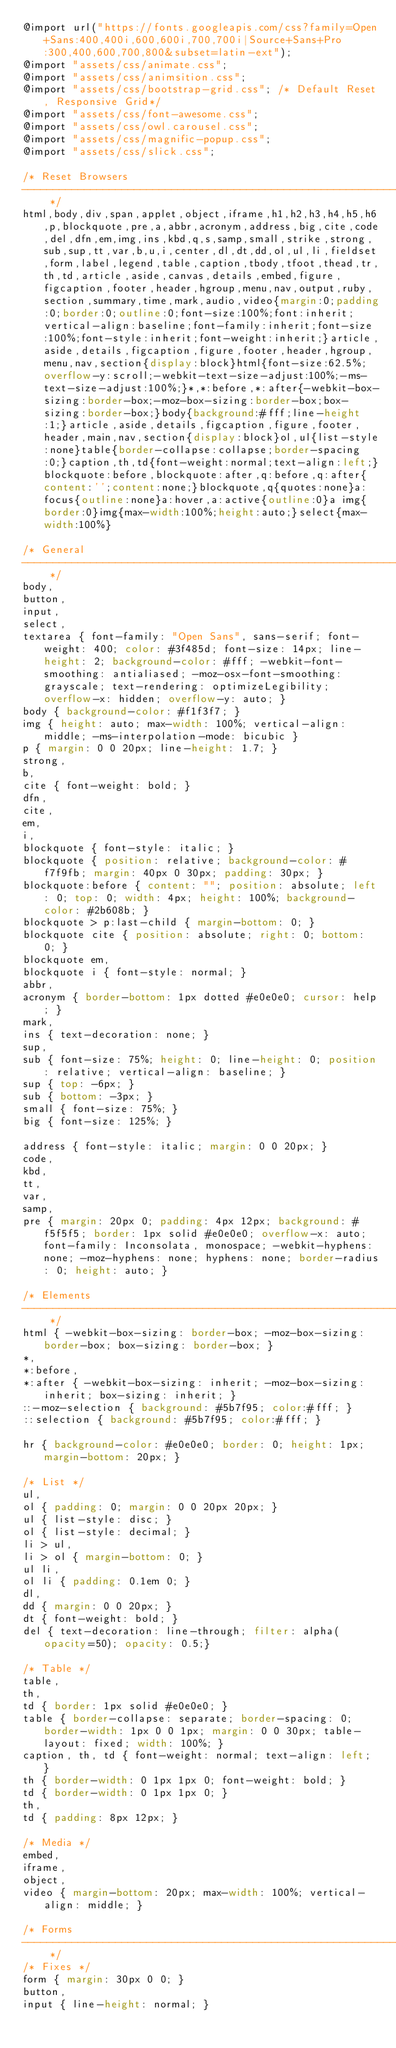<code> <loc_0><loc_0><loc_500><loc_500><_CSS_>@import url("https://fonts.googleapis.com/css?family=Open+Sans:400,400i,600,600i,700,700i|Source+Sans+Pro:300,400,600,700,800&subset=latin-ext");
@import "assets/css/animate.css";
@import "assets/css/animsition.css";
@import "assets/css/bootstrap-grid.css"; /* Default Reset, Responsive Grid*/
@import "assets/css/font-awesome.css";
@import "assets/css/owl.carousel.css";
@import "assets/css/magnific-popup.css";
@import "assets/css/slick.css";

/* Reset Browsers
-------------------------------------------------------------- */
html,body,div,span,applet,object,iframe,h1,h2,h3,h4,h5,h6,p,blockquote,pre,a,abbr,acronym,address,big,cite,code,del,dfn,em,img,ins,kbd,q,s,samp,small,strike,strong,sub,sup,tt,var,b,u,i,center,dl,dt,dd,ol,ul,li,fieldset,form,label,legend,table,caption,tbody,tfoot,thead,tr,th,td,article,aside,canvas,details,embed,figure,figcaption,footer,header,hgroup,menu,nav,output,ruby,section,summary,time,mark,audio,video{margin:0;padding:0;border:0;outline:0;font-size:100%;font:inherit;vertical-align:baseline;font-family:inherit;font-size:100%;font-style:inherit;font-weight:inherit;}article,aside,details,figcaption,figure,footer,header,hgroup,menu,nav,section{display:block}html{font-size:62.5%;overflow-y:scroll;-webkit-text-size-adjust:100%;-ms-text-size-adjust:100%;}*,*:before,*:after{-webkit-box-sizing:border-box;-moz-box-sizing:border-box;box-sizing:border-box;}body{background:#fff;line-height:1;}article,aside,details,figcaption,figure,footer,header,main,nav,section{display:block}ol,ul{list-style:none}table{border-collapse:collapse;border-spacing:0;}caption,th,td{font-weight:normal;text-align:left;}blockquote:before,blockquote:after,q:before,q:after{content:'';content:none;}blockquote,q{quotes:none}a:focus{outline:none}a:hover,a:active{outline:0}a img{border:0}img{max-width:100%;height:auto;}select{max-width:100%}

/* General
-------------------------------------------------------------- */
body,
button,
input,
select,
textarea { font-family: "Open Sans", sans-serif; font-weight: 400; color: #3f485d; font-size: 14px; line-height: 2; background-color: #fff; -webkit-font-smoothing: antialiased; -moz-osx-font-smoothing: grayscale; text-rendering: optimizeLegibility; overflow-x: hidden; overflow-y: auto; }
body { background-color: #f1f3f7; }
img { height: auto; max-width: 100%; vertical-align: middle; -ms-interpolation-mode: bicubic }
p { margin: 0 0 20px; line-height: 1.7; }
strong,
b,
cite { font-weight: bold; }
dfn,
cite,
em,
i,
blockquote { font-style: italic; }
blockquote { position: relative; background-color: #f7f9fb; margin: 40px 0 30px; padding: 30px; }
blockquote:before { content: ""; position: absolute; left: 0; top: 0; width: 4px; height: 100%; background-color: #2b608b; }
blockquote > p:last-child { margin-bottom: 0; }
blockquote cite { position: absolute; right: 0; bottom: 0; }
blockquote em,
blockquote i { font-style: normal; }
abbr,
acronym { border-bottom: 1px dotted #e0e0e0; cursor: help; }
mark,
ins { text-decoration: none; }
sup,
sub { font-size: 75%; height: 0; line-height: 0; position: relative; vertical-align: baseline; }
sup { top: -6px; }
sub { bottom: -3px; }
small { font-size: 75%; }
big { font-size: 125%; }

address { font-style: italic; margin: 0 0 20px; }
code,
kbd,
tt,
var,
samp,
pre { margin: 20px 0; padding: 4px 12px; background: #f5f5f5; border: 1px solid #e0e0e0; overflow-x: auto; font-family: Inconsolata, monospace; -webkit-hyphens: none; -moz-hyphens: none; hyphens: none; border-radius: 0; height: auto; }

/* Elements
-------------------------------------------------------------- */
html { -webkit-box-sizing: border-box; -moz-box-sizing: border-box; box-sizing: border-box; }
*,
*:before,
*:after { -webkit-box-sizing: inherit; -moz-box-sizing: inherit; box-sizing: inherit; }
::-moz-selection { background: #5b7f95; color:#fff; }
::selection { background: #5b7f95; color:#fff; }

hr { background-color: #e0e0e0; border: 0; height: 1px; margin-bottom: 20px; }

/* List */
ul,
ol { padding: 0; margin: 0 0 20px 20px; }
ul { list-style: disc; }
ol { list-style: decimal; }
li > ul,
li > ol { margin-bottom: 0; }
ul li,
ol li { padding: 0.1em 0; }
dl,
dd { margin: 0 0 20px; }
dt { font-weight: bold; }
del { text-decoration: line-through; filter: alpha(opacity=50); opacity: 0.5;}

/* Table */
table,
th,
td { border: 1px solid #e0e0e0; }
table { border-collapse: separate; border-spacing: 0; border-width: 1px 0 0 1px; margin: 0 0 30px; table-layout: fixed; width: 100%; }
caption, th, td { font-weight: normal; text-align: left; }
th { border-width: 0 1px 1px 0; font-weight: bold; }
td { border-width: 0 1px 1px 0; }
th,
td { padding: 8px 12px; }

/* Media */
embed,
iframe,
object,
video { margin-bottom: 20px; max-width: 100%; vertical-align: middle; }

/* Forms
-------------------------------------------------------------- */
/* Fixes */
form { margin: 30px 0 0; }
button,
input { line-height: normal; }</code> 